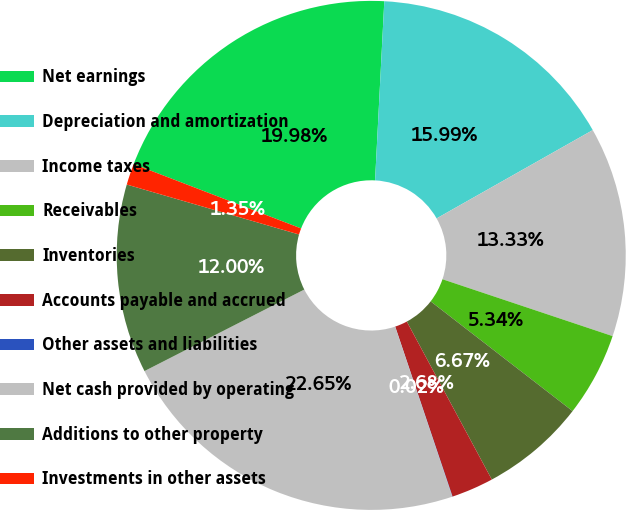Convert chart to OTSL. <chart><loc_0><loc_0><loc_500><loc_500><pie_chart><fcel>Net earnings<fcel>Depreciation and amortization<fcel>Income taxes<fcel>Receivables<fcel>Inventories<fcel>Accounts payable and accrued<fcel>Other assets and liabilities<fcel>Net cash provided by operating<fcel>Additions to other property<fcel>Investments in other assets<nl><fcel>19.98%<fcel>15.99%<fcel>13.33%<fcel>5.34%<fcel>6.67%<fcel>2.68%<fcel>0.02%<fcel>22.65%<fcel>12.0%<fcel>1.35%<nl></chart> 